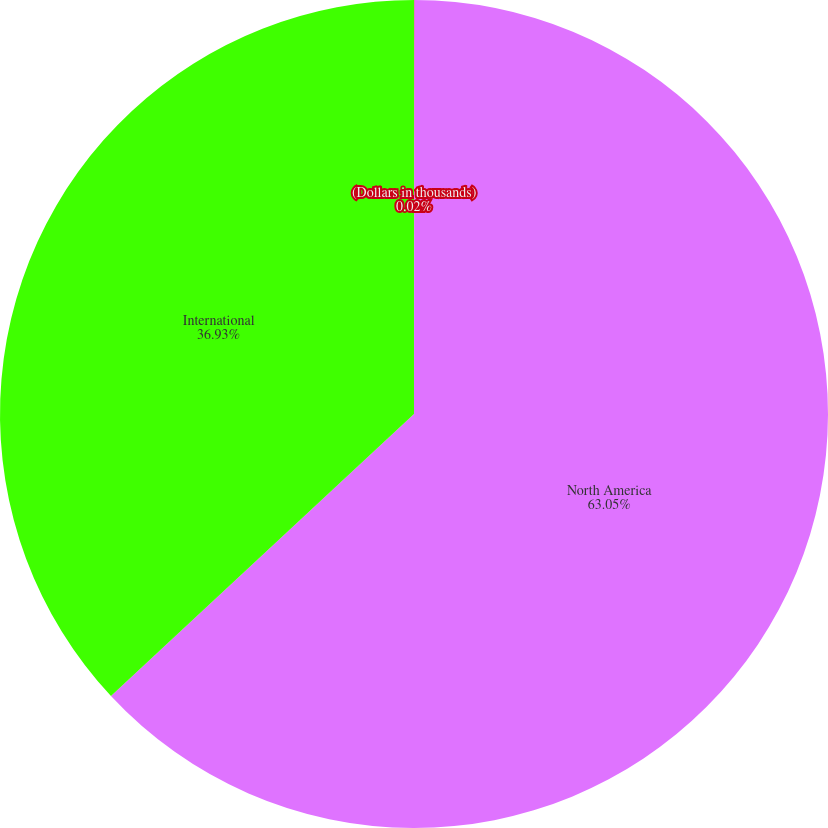Convert chart. <chart><loc_0><loc_0><loc_500><loc_500><pie_chart><fcel>(Dollars in thousands)<fcel>North America<fcel>International<nl><fcel>0.02%<fcel>63.05%<fcel>36.93%<nl></chart> 